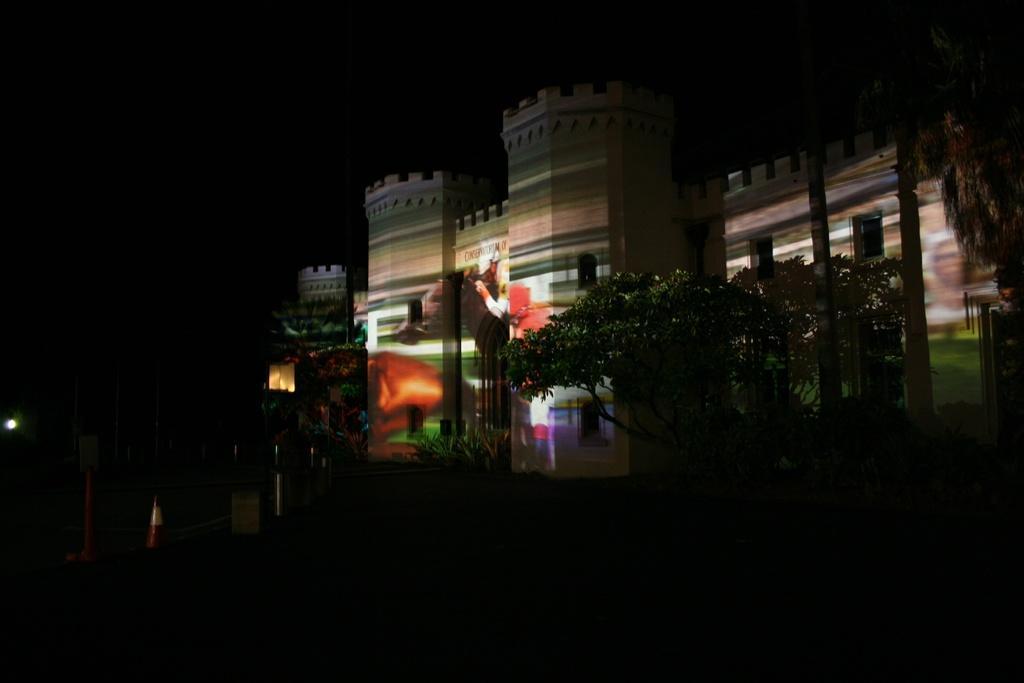Could you give a brief overview of what you see in this image? Here in this picture we can see an old monumental building with number of windows present over a place and we can see some colorful lights on it and we can also see plants and trees present. 